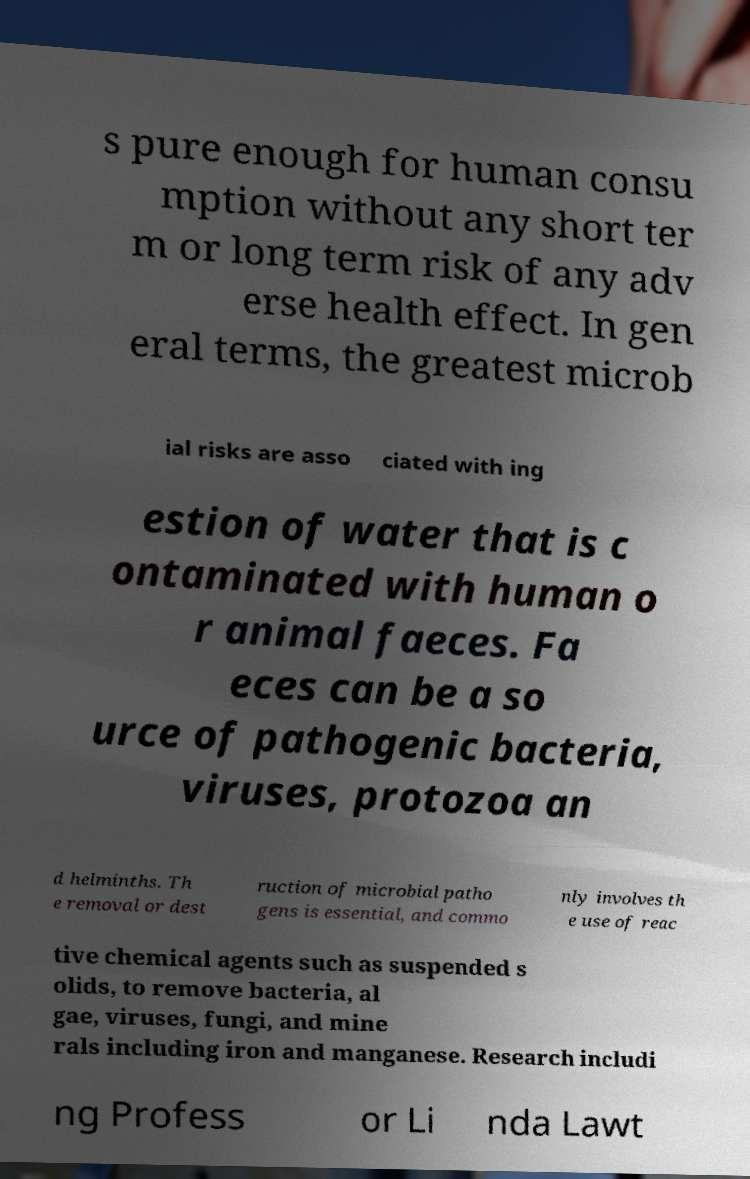What messages or text are displayed in this image? I need them in a readable, typed format. s pure enough for human consu mption without any short ter m or long term risk of any adv erse health effect. In gen eral terms, the greatest microb ial risks are asso ciated with ing estion of water that is c ontaminated with human o r animal faeces. Fa eces can be a so urce of pathogenic bacteria, viruses, protozoa an d helminths. Th e removal or dest ruction of microbial patho gens is essential, and commo nly involves th e use of reac tive chemical agents such as suspended s olids, to remove bacteria, al gae, viruses, fungi, and mine rals including iron and manganese. Research includi ng Profess or Li nda Lawt 